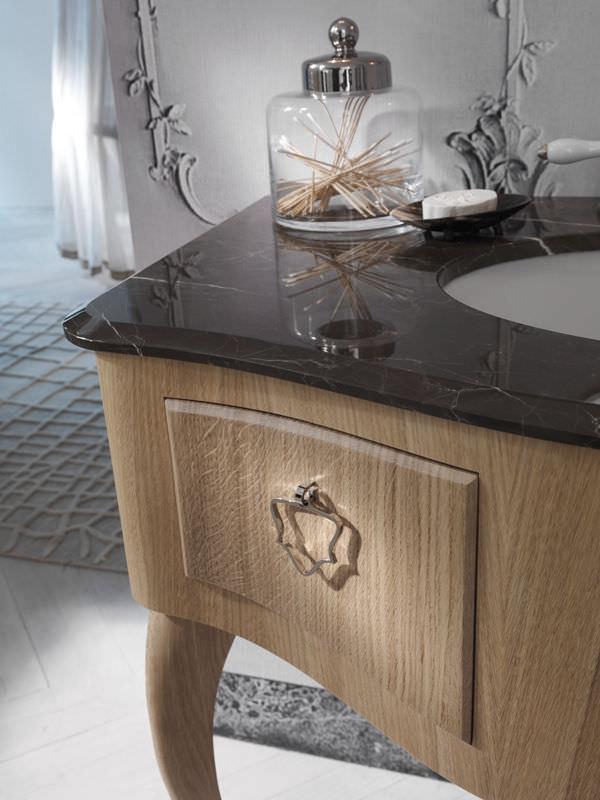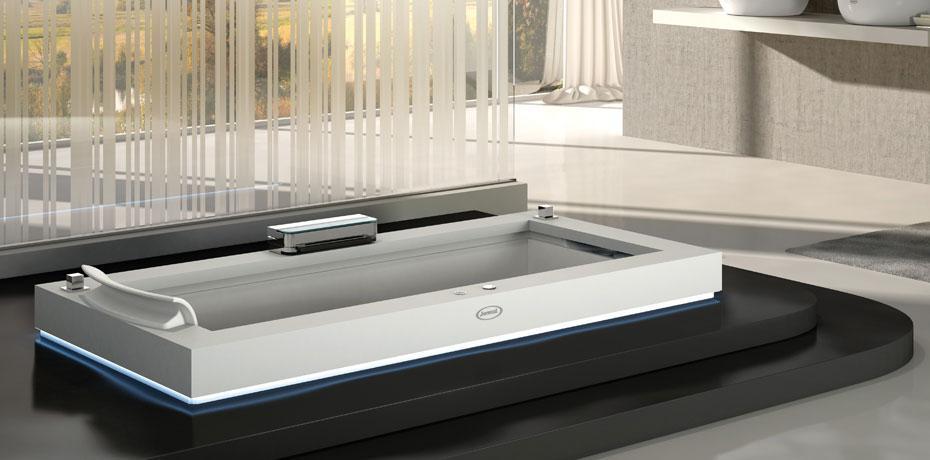The first image is the image on the left, the second image is the image on the right. Given the left and right images, does the statement "One of images shows folded towels stored beneath the sink." hold true? Answer yes or no. No. The first image is the image on the left, the second image is the image on the right. For the images shown, is this caption "One sink is round and the other is rectangular; also, one sink is inset, and the other is elevated above the counter." true? Answer yes or no. Yes. 